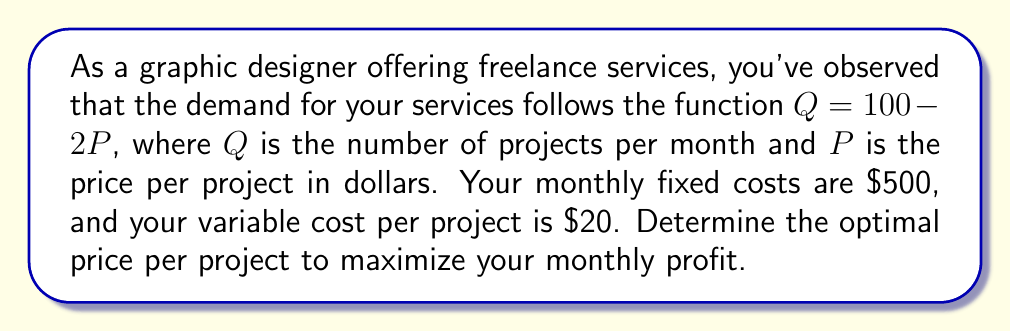What is the answer to this math problem? To solve this problem, we'll follow these steps:

1) First, let's define the profit function. Profit is revenue minus costs:
   $\text{Profit} = \text{Revenue} - \text{Total Costs}$

2) Revenue is price times quantity:
   $\text{Revenue} = P \cdot Q = P \cdot (100 - 2P) = 100P - 2P^2$

3) Total costs are fixed costs plus variable costs times quantity:
   $\text{Total Costs} = 500 + 20Q = 500 + 20(100 - 2P) = 2500 - 40P$

4) Now we can write the profit function:
   $\text{Profit} = (100P - 2P^2) - (2500 - 40P)$
   $\text{Profit} = 100P - 2P^2 - 2500 + 40P$
   $\text{Profit} = -2P^2 + 140P - 2500$

5) To find the maximum profit, we need to find where the derivative of the profit function equals zero:
   $\frac{d\text{Profit}}{dP} = -4P + 140 = 0$

6) Solving this equation:
   $-4P + 140 = 0$
   $-4P = -140$
   $P = 35$

7) To confirm this is a maximum (not a minimum), we can check the second derivative:
   $\frac{d^2\text{Profit}}{dP^2} = -4$, which is negative, confirming a maximum.

8) Therefore, the optimal price is $35 per project.

9) At this price, the quantity demanded will be:
   $Q = 100 - 2P = 100 - 2(35) = 30$ projects per month

10) We can verify the profit at this point:
    $\text{Profit} = -2(35)^2 + 140(35) - 2500 = -2450 + 4900 - 2500 = -50$

Thus, the maximum monthly profit is $-50, which actually represents a loss. This suggests that with the given cost structure and demand function, the business is not profitable at any price point.
Answer: The optimal price is $35 per project, but this results in a monthly loss of $50. The business is not profitable under these conditions. 